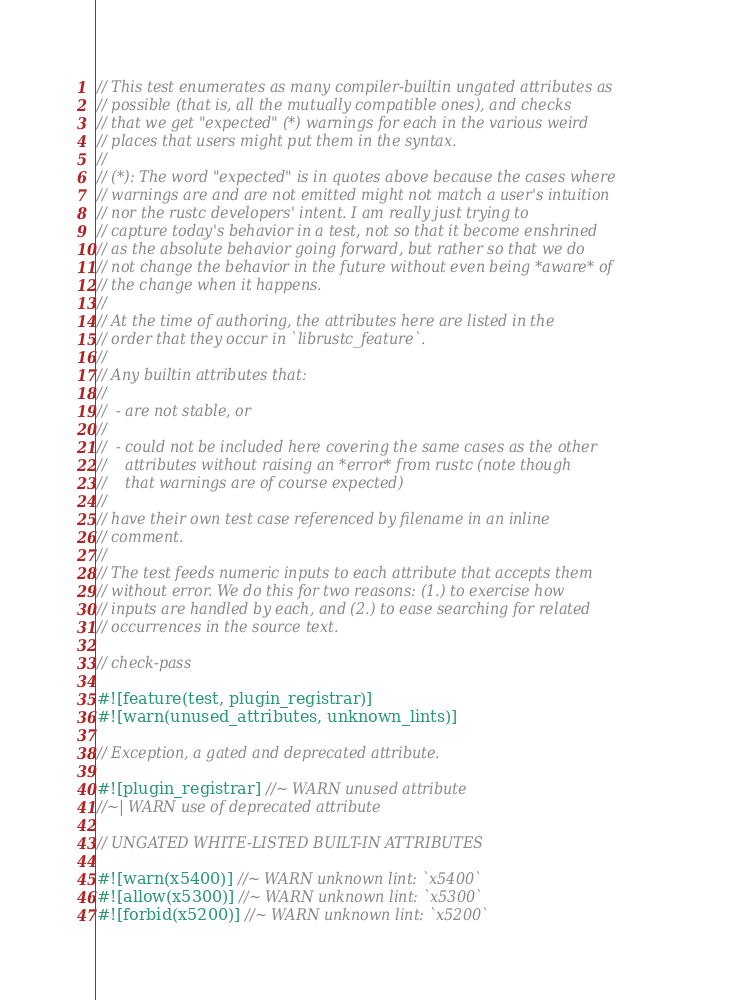<code> <loc_0><loc_0><loc_500><loc_500><_Rust_>// This test enumerates as many compiler-builtin ungated attributes as
// possible (that is, all the mutually compatible ones), and checks
// that we get "expected" (*) warnings for each in the various weird
// places that users might put them in the syntax.
//
// (*): The word "expected" is in quotes above because the cases where
// warnings are and are not emitted might not match a user's intuition
// nor the rustc developers' intent. I am really just trying to
// capture today's behavior in a test, not so that it become enshrined
// as the absolute behavior going forward, but rather so that we do
// not change the behavior in the future without even being *aware* of
// the change when it happens.
//
// At the time of authoring, the attributes here are listed in the
// order that they occur in `librustc_feature`.
//
// Any builtin attributes that:
//
//  - are not stable, or
//
//  - could not be included here covering the same cases as the other
//    attributes without raising an *error* from rustc (note though
//    that warnings are of course expected)
//
// have their own test case referenced by filename in an inline
// comment.
//
// The test feeds numeric inputs to each attribute that accepts them
// without error. We do this for two reasons: (1.) to exercise how
// inputs are handled by each, and (2.) to ease searching for related
// occurrences in the source text.

// check-pass

#![feature(test, plugin_registrar)]
#![warn(unused_attributes, unknown_lints)]

// Exception, a gated and deprecated attribute.

#![plugin_registrar] //~ WARN unused attribute
//~| WARN use of deprecated attribute

// UNGATED WHITE-LISTED BUILT-IN ATTRIBUTES

#![warn(x5400)] //~ WARN unknown lint: `x5400`
#![allow(x5300)] //~ WARN unknown lint: `x5300`
#![forbid(x5200)] //~ WARN unknown lint: `x5200`</code> 